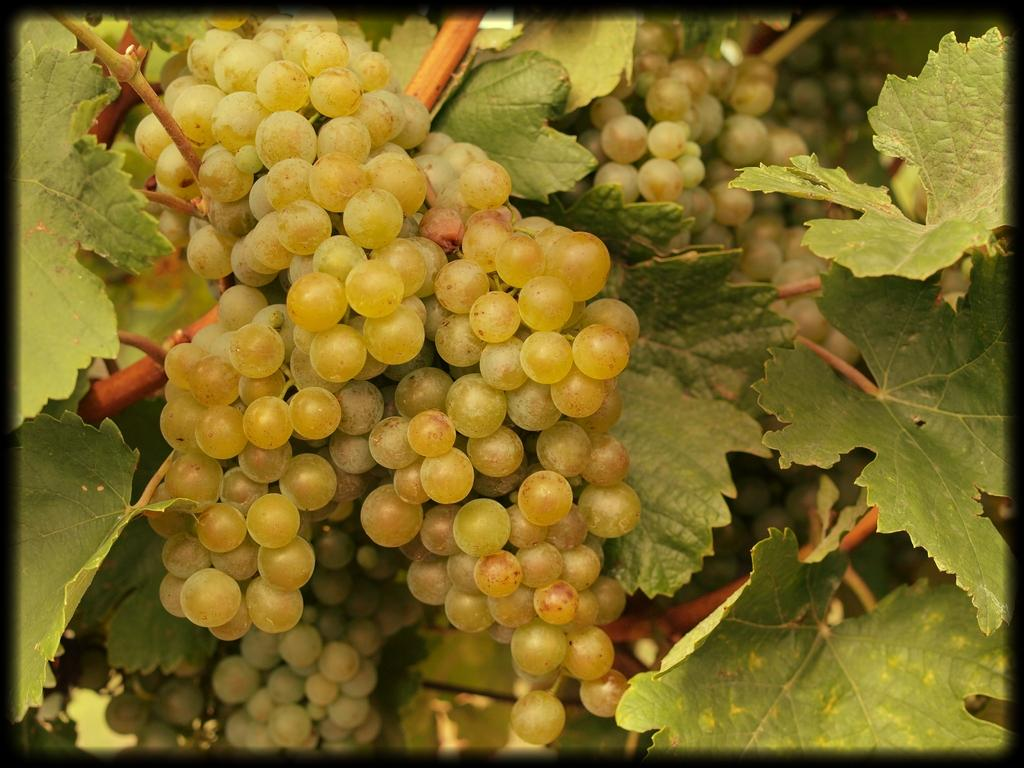What type of fruit is visible in the image? There are grapes in the image. What else can be seen in the image besides the grapes? There are leaves in the image, likely belonging to a tree. What is the current debt situation of the grapes in the image? There is no information about the debt situation of the grapes in the image, as grapes do not have financial obligations. 